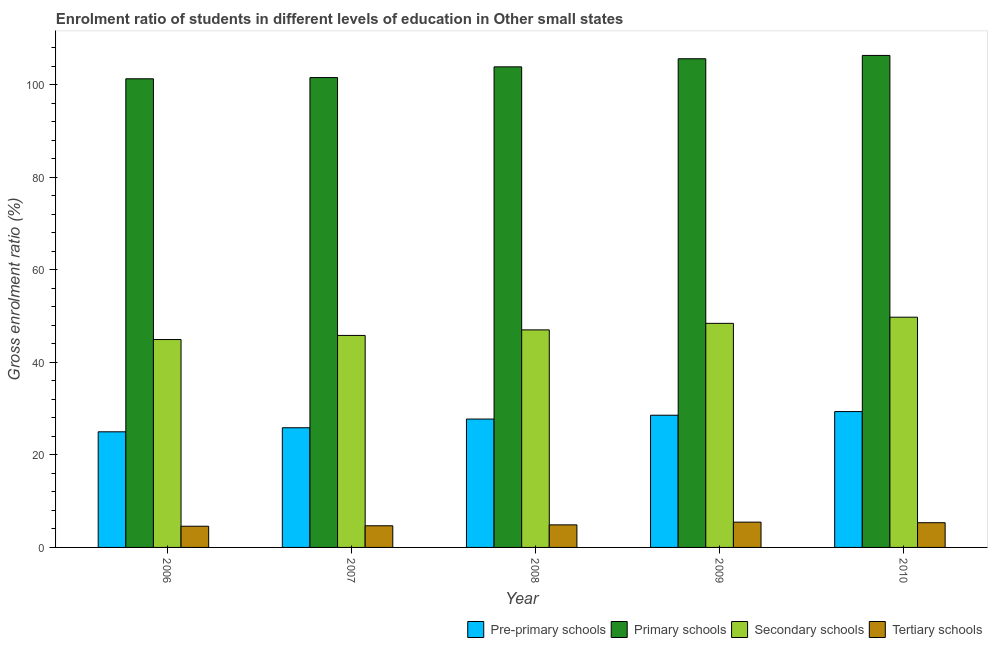How many different coloured bars are there?
Give a very brief answer. 4. How many groups of bars are there?
Offer a very short reply. 5. Are the number of bars per tick equal to the number of legend labels?
Make the answer very short. Yes. Are the number of bars on each tick of the X-axis equal?
Keep it short and to the point. Yes. How many bars are there on the 1st tick from the right?
Provide a succinct answer. 4. What is the label of the 5th group of bars from the left?
Your answer should be very brief. 2010. In how many cases, is the number of bars for a given year not equal to the number of legend labels?
Your response must be concise. 0. What is the gross enrolment ratio in primary schools in 2007?
Provide a short and direct response. 101.54. Across all years, what is the maximum gross enrolment ratio in tertiary schools?
Give a very brief answer. 5.46. Across all years, what is the minimum gross enrolment ratio in primary schools?
Offer a very short reply. 101.28. In which year was the gross enrolment ratio in pre-primary schools minimum?
Give a very brief answer. 2006. What is the total gross enrolment ratio in primary schools in the graph?
Keep it short and to the point. 518.62. What is the difference between the gross enrolment ratio in tertiary schools in 2007 and that in 2010?
Give a very brief answer. -0.66. What is the difference between the gross enrolment ratio in tertiary schools in 2010 and the gross enrolment ratio in pre-primary schools in 2009?
Give a very brief answer. -0.12. What is the average gross enrolment ratio in pre-primary schools per year?
Provide a succinct answer. 27.3. In the year 2009, what is the difference between the gross enrolment ratio in pre-primary schools and gross enrolment ratio in tertiary schools?
Offer a terse response. 0. What is the ratio of the gross enrolment ratio in pre-primary schools in 2007 to that in 2008?
Ensure brevity in your answer.  0.93. Is the difference between the gross enrolment ratio in pre-primary schools in 2007 and 2010 greater than the difference between the gross enrolment ratio in primary schools in 2007 and 2010?
Your response must be concise. No. What is the difference between the highest and the second highest gross enrolment ratio in tertiary schools?
Your response must be concise. 0.12. What is the difference between the highest and the lowest gross enrolment ratio in pre-primary schools?
Your answer should be compact. 4.37. Is it the case that in every year, the sum of the gross enrolment ratio in pre-primary schools and gross enrolment ratio in primary schools is greater than the sum of gross enrolment ratio in tertiary schools and gross enrolment ratio in secondary schools?
Provide a short and direct response. No. What does the 3rd bar from the left in 2007 represents?
Give a very brief answer. Secondary schools. What does the 2nd bar from the right in 2008 represents?
Give a very brief answer. Secondary schools. Is it the case that in every year, the sum of the gross enrolment ratio in pre-primary schools and gross enrolment ratio in primary schools is greater than the gross enrolment ratio in secondary schools?
Give a very brief answer. Yes. How many bars are there?
Offer a terse response. 20. Are all the bars in the graph horizontal?
Make the answer very short. No. How many years are there in the graph?
Offer a very short reply. 5. What is the difference between two consecutive major ticks on the Y-axis?
Your answer should be compact. 20. Are the values on the major ticks of Y-axis written in scientific E-notation?
Ensure brevity in your answer.  No. Does the graph contain any zero values?
Offer a terse response. No. Does the graph contain grids?
Your answer should be very brief. No. Where does the legend appear in the graph?
Your answer should be very brief. Bottom right. How many legend labels are there?
Keep it short and to the point. 4. What is the title of the graph?
Offer a terse response. Enrolment ratio of students in different levels of education in Other small states. What is the Gross enrolment ratio (%) of Pre-primary schools in 2006?
Your answer should be compact. 24.99. What is the Gross enrolment ratio (%) in Primary schools in 2006?
Your answer should be very brief. 101.28. What is the Gross enrolment ratio (%) in Secondary schools in 2006?
Offer a very short reply. 44.93. What is the Gross enrolment ratio (%) in Tertiary schools in 2006?
Provide a succinct answer. 4.58. What is the Gross enrolment ratio (%) of Pre-primary schools in 2007?
Your answer should be very brief. 25.86. What is the Gross enrolment ratio (%) of Primary schools in 2007?
Make the answer very short. 101.54. What is the Gross enrolment ratio (%) of Secondary schools in 2007?
Offer a very short reply. 45.82. What is the Gross enrolment ratio (%) in Tertiary schools in 2007?
Offer a very short reply. 4.68. What is the Gross enrolment ratio (%) in Pre-primary schools in 2008?
Make the answer very short. 27.74. What is the Gross enrolment ratio (%) in Primary schools in 2008?
Ensure brevity in your answer.  103.86. What is the Gross enrolment ratio (%) in Secondary schools in 2008?
Offer a very short reply. 47.01. What is the Gross enrolment ratio (%) in Tertiary schools in 2008?
Your answer should be compact. 4.88. What is the Gross enrolment ratio (%) in Pre-primary schools in 2009?
Your answer should be compact. 28.57. What is the Gross enrolment ratio (%) in Primary schools in 2009?
Your response must be concise. 105.61. What is the Gross enrolment ratio (%) in Secondary schools in 2009?
Offer a very short reply. 48.43. What is the Gross enrolment ratio (%) of Tertiary schools in 2009?
Provide a succinct answer. 5.46. What is the Gross enrolment ratio (%) in Pre-primary schools in 2010?
Offer a very short reply. 29.36. What is the Gross enrolment ratio (%) in Primary schools in 2010?
Make the answer very short. 106.33. What is the Gross enrolment ratio (%) in Secondary schools in 2010?
Provide a short and direct response. 49.76. What is the Gross enrolment ratio (%) in Tertiary schools in 2010?
Offer a very short reply. 5.34. Across all years, what is the maximum Gross enrolment ratio (%) of Pre-primary schools?
Offer a terse response. 29.36. Across all years, what is the maximum Gross enrolment ratio (%) in Primary schools?
Your response must be concise. 106.33. Across all years, what is the maximum Gross enrolment ratio (%) of Secondary schools?
Ensure brevity in your answer.  49.76. Across all years, what is the maximum Gross enrolment ratio (%) of Tertiary schools?
Your answer should be compact. 5.46. Across all years, what is the minimum Gross enrolment ratio (%) of Pre-primary schools?
Offer a terse response. 24.99. Across all years, what is the minimum Gross enrolment ratio (%) of Primary schools?
Provide a succinct answer. 101.28. Across all years, what is the minimum Gross enrolment ratio (%) in Secondary schools?
Your response must be concise. 44.93. Across all years, what is the minimum Gross enrolment ratio (%) of Tertiary schools?
Offer a terse response. 4.58. What is the total Gross enrolment ratio (%) of Pre-primary schools in the graph?
Offer a terse response. 136.52. What is the total Gross enrolment ratio (%) of Primary schools in the graph?
Your response must be concise. 518.62. What is the total Gross enrolment ratio (%) in Secondary schools in the graph?
Keep it short and to the point. 235.94. What is the total Gross enrolment ratio (%) of Tertiary schools in the graph?
Your response must be concise. 24.94. What is the difference between the Gross enrolment ratio (%) in Pre-primary schools in 2006 and that in 2007?
Offer a terse response. -0.88. What is the difference between the Gross enrolment ratio (%) of Primary schools in 2006 and that in 2007?
Provide a short and direct response. -0.26. What is the difference between the Gross enrolment ratio (%) in Secondary schools in 2006 and that in 2007?
Your response must be concise. -0.89. What is the difference between the Gross enrolment ratio (%) in Tertiary schools in 2006 and that in 2007?
Provide a short and direct response. -0.1. What is the difference between the Gross enrolment ratio (%) in Pre-primary schools in 2006 and that in 2008?
Ensure brevity in your answer.  -2.76. What is the difference between the Gross enrolment ratio (%) of Primary schools in 2006 and that in 2008?
Your answer should be compact. -2.58. What is the difference between the Gross enrolment ratio (%) in Secondary schools in 2006 and that in 2008?
Offer a very short reply. -2.09. What is the difference between the Gross enrolment ratio (%) of Tertiary schools in 2006 and that in 2008?
Offer a terse response. -0.3. What is the difference between the Gross enrolment ratio (%) of Pre-primary schools in 2006 and that in 2009?
Your response must be concise. -3.59. What is the difference between the Gross enrolment ratio (%) of Primary schools in 2006 and that in 2009?
Provide a short and direct response. -4.33. What is the difference between the Gross enrolment ratio (%) in Secondary schools in 2006 and that in 2009?
Your response must be concise. -3.5. What is the difference between the Gross enrolment ratio (%) in Tertiary schools in 2006 and that in 2009?
Your answer should be very brief. -0.88. What is the difference between the Gross enrolment ratio (%) in Pre-primary schools in 2006 and that in 2010?
Your answer should be very brief. -4.37. What is the difference between the Gross enrolment ratio (%) of Primary schools in 2006 and that in 2010?
Your response must be concise. -5.05. What is the difference between the Gross enrolment ratio (%) in Secondary schools in 2006 and that in 2010?
Offer a terse response. -4.83. What is the difference between the Gross enrolment ratio (%) of Tertiary schools in 2006 and that in 2010?
Your response must be concise. -0.76. What is the difference between the Gross enrolment ratio (%) of Pre-primary schools in 2007 and that in 2008?
Provide a succinct answer. -1.88. What is the difference between the Gross enrolment ratio (%) of Primary schools in 2007 and that in 2008?
Make the answer very short. -2.32. What is the difference between the Gross enrolment ratio (%) of Secondary schools in 2007 and that in 2008?
Provide a short and direct response. -1.2. What is the difference between the Gross enrolment ratio (%) of Tertiary schools in 2007 and that in 2008?
Keep it short and to the point. -0.2. What is the difference between the Gross enrolment ratio (%) in Pre-primary schools in 2007 and that in 2009?
Keep it short and to the point. -2.71. What is the difference between the Gross enrolment ratio (%) of Primary schools in 2007 and that in 2009?
Offer a very short reply. -4.07. What is the difference between the Gross enrolment ratio (%) of Secondary schools in 2007 and that in 2009?
Ensure brevity in your answer.  -2.61. What is the difference between the Gross enrolment ratio (%) in Tertiary schools in 2007 and that in 2009?
Ensure brevity in your answer.  -0.78. What is the difference between the Gross enrolment ratio (%) in Pre-primary schools in 2007 and that in 2010?
Your answer should be very brief. -3.49. What is the difference between the Gross enrolment ratio (%) of Primary schools in 2007 and that in 2010?
Give a very brief answer. -4.79. What is the difference between the Gross enrolment ratio (%) in Secondary schools in 2007 and that in 2010?
Your response must be concise. -3.94. What is the difference between the Gross enrolment ratio (%) in Tertiary schools in 2007 and that in 2010?
Offer a very short reply. -0.66. What is the difference between the Gross enrolment ratio (%) in Pre-primary schools in 2008 and that in 2009?
Your response must be concise. -0.83. What is the difference between the Gross enrolment ratio (%) in Primary schools in 2008 and that in 2009?
Your response must be concise. -1.75. What is the difference between the Gross enrolment ratio (%) in Secondary schools in 2008 and that in 2009?
Your answer should be compact. -1.41. What is the difference between the Gross enrolment ratio (%) of Tertiary schools in 2008 and that in 2009?
Your response must be concise. -0.59. What is the difference between the Gross enrolment ratio (%) of Pre-primary schools in 2008 and that in 2010?
Keep it short and to the point. -1.61. What is the difference between the Gross enrolment ratio (%) in Primary schools in 2008 and that in 2010?
Your answer should be very brief. -2.47. What is the difference between the Gross enrolment ratio (%) in Secondary schools in 2008 and that in 2010?
Your response must be concise. -2.74. What is the difference between the Gross enrolment ratio (%) in Tertiary schools in 2008 and that in 2010?
Offer a very short reply. -0.47. What is the difference between the Gross enrolment ratio (%) in Pre-primary schools in 2009 and that in 2010?
Provide a succinct answer. -0.79. What is the difference between the Gross enrolment ratio (%) of Primary schools in 2009 and that in 2010?
Your answer should be very brief. -0.72. What is the difference between the Gross enrolment ratio (%) of Secondary schools in 2009 and that in 2010?
Give a very brief answer. -1.33. What is the difference between the Gross enrolment ratio (%) of Tertiary schools in 2009 and that in 2010?
Offer a terse response. 0.12. What is the difference between the Gross enrolment ratio (%) of Pre-primary schools in 2006 and the Gross enrolment ratio (%) of Primary schools in 2007?
Provide a short and direct response. -76.56. What is the difference between the Gross enrolment ratio (%) of Pre-primary schools in 2006 and the Gross enrolment ratio (%) of Secondary schools in 2007?
Make the answer very short. -20.83. What is the difference between the Gross enrolment ratio (%) of Pre-primary schools in 2006 and the Gross enrolment ratio (%) of Tertiary schools in 2007?
Your answer should be very brief. 20.31. What is the difference between the Gross enrolment ratio (%) in Primary schools in 2006 and the Gross enrolment ratio (%) in Secondary schools in 2007?
Offer a terse response. 55.46. What is the difference between the Gross enrolment ratio (%) in Primary schools in 2006 and the Gross enrolment ratio (%) in Tertiary schools in 2007?
Give a very brief answer. 96.6. What is the difference between the Gross enrolment ratio (%) in Secondary schools in 2006 and the Gross enrolment ratio (%) in Tertiary schools in 2007?
Provide a succinct answer. 40.25. What is the difference between the Gross enrolment ratio (%) in Pre-primary schools in 2006 and the Gross enrolment ratio (%) in Primary schools in 2008?
Offer a terse response. -78.87. What is the difference between the Gross enrolment ratio (%) in Pre-primary schools in 2006 and the Gross enrolment ratio (%) in Secondary schools in 2008?
Offer a terse response. -22.03. What is the difference between the Gross enrolment ratio (%) of Pre-primary schools in 2006 and the Gross enrolment ratio (%) of Tertiary schools in 2008?
Your answer should be very brief. 20.11. What is the difference between the Gross enrolment ratio (%) in Primary schools in 2006 and the Gross enrolment ratio (%) in Secondary schools in 2008?
Keep it short and to the point. 54.26. What is the difference between the Gross enrolment ratio (%) in Primary schools in 2006 and the Gross enrolment ratio (%) in Tertiary schools in 2008?
Provide a short and direct response. 96.4. What is the difference between the Gross enrolment ratio (%) in Secondary schools in 2006 and the Gross enrolment ratio (%) in Tertiary schools in 2008?
Offer a very short reply. 40.05. What is the difference between the Gross enrolment ratio (%) in Pre-primary schools in 2006 and the Gross enrolment ratio (%) in Primary schools in 2009?
Ensure brevity in your answer.  -80.62. What is the difference between the Gross enrolment ratio (%) of Pre-primary schools in 2006 and the Gross enrolment ratio (%) of Secondary schools in 2009?
Your answer should be compact. -23.44. What is the difference between the Gross enrolment ratio (%) of Pre-primary schools in 2006 and the Gross enrolment ratio (%) of Tertiary schools in 2009?
Provide a succinct answer. 19.52. What is the difference between the Gross enrolment ratio (%) of Primary schools in 2006 and the Gross enrolment ratio (%) of Secondary schools in 2009?
Ensure brevity in your answer.  52.85. What is the difference between the Gross enrolment ratio (%) in Primary schools in 2006 and the Gross enrolment ratio (%) in Tertiary schools in 2009?
Make the answer very short. 95.81. What is the difference between the Gross enrolment ratio (%) in Secondary schools in 2006 and the Gross enrolment ratio (%) in Tertiary schools in 2009?
Make the answer very short. 39.46. What is the difference between the Gross enrolment ratio (%) of Pre-primary schools in 2006 and the Gross enrolment ratio (%) of Primary schools in 2010?
Ensure brevity in your answer.  -81.34. What is the difference between the Gross enrolment ratio (%) of Pre-primary schools in 2006 and the Gross enrolment ratio (%) of Secondary schools in 2010?
Provide a succinct answer. -24.77. What is the difference between the Gross enrolment ratio (%) in Pre-primary schools in 2006 and the Gross enrolment ratio (%) in Tertiary schools in 2010?
Your answer should be very brief. 19.64. What is the difference between the Gross enrolment ratio (%) in Primary schools in 2006 and the Gross enrolment ratio (%) in Secondary schools in 2010?
Your response must be concise. 51.52. What is the difference between the Gross enrolment ratio (%) of Primary schools in 2006 and the Gross enrolment ratio (%) of Tertiary schools in 2010?
Your answer should be very brief. 95.94. What is the difference between the Gross enrolment ratio (%) in Secondary schools in 2006 and the Gross enrolment ratio (%) in Tertiary schools in 2010?
Your answer should be compact. 39.59. What is the difference between the Gross enrolment ratio (%) in Pre-primary schools in 2007 and the Gross enrolment ratio (%) in Primary schools in 2008?
Your response must be concise. -78. What is the difference between the Gross enrolment ratio (%) of Pre-primary schools in 2007 and the Gross enrolment ratio (%) of Secondary schools in 2008?
Give a very brief answer. -21.15. What is the difference between the Gross enrolment ratio (%) in Pre-primary schools in 2007 and the Gross enrolment ratio (%) in Tertiary schools in 2008?
Make the answer very short. 20.99. What is the difference between the Gross enrolment ratio (%) in Primary schools in 2007 and the Gross enrolment ratio (%) in Secondary schools in 2008?
Give a very brief answer. 54.53. What is the difference between the Gross enrolment ratio (%) in Primary schools in 2007 and the Gross enrolment ratio (%) in Tertiary schools in 2008?
Your answer should be compact. 96.67. What is the difference between the Gross enrolment ratio (%) of Secondary schools in 2007 and the Gross enrolment ratio (%) of Tertiary schools in 2008?
Keep it short and to the point. 40.94. What is the difference between the Gross enrolment ratio (%) of Pre-primary schools in 2007 and the Gross enrolment ratio (%) of Primary schools in 2009?
Provide a succinct answer. -79.75. What is the difference between the Gross enrolment ratio (%) of Pre-primary schools in 2007 and the Gross enrolment ratio (%) of Secondary schools in 2009?
Make the answer very short. -22.56. What is the difference between the Gross enrolment ratio (%) in Pre-primary schools in 2007 and the Gross enrolment ratio (%) in Tertiary schools in 2009?
Offer a very short reply. 20.4. What is the difference between the Gross enrolment ratio (%) in Primary schools in 2007 and the Gross enrolment ratio (%) in Secondary schools in 2009?
Offer a terse response. 53.12. What is the difference between the Gross enrolment ratio (%) of Primary schools in 2007 and the Gross enrolment ratio (%) of Tertiary schools in 2009?
Offer a terse response. 96.08. What is the difference between the Gross enrolment ratio (%) in Secondary schools in 2007 and the Gross enrolment ratio (%) in Tertiary schools in 2009?
Make the answer very short. 40.35. What is the difference between the Gross enrolment ratio (%) of Pre-primary schools in 2007 and the Gross enrolment ratio (%) of Primary schools in 2010?
Offer a terse response. -80.47. What is the difference between the Gross enrolment ratio (%) of Pre-primary schools in 2007 and the Gross enrolment ratio (%) of Secondary schools in 2010?
Ensure brevity in your answer.  -23.89. What is the difference between the Gross enrolment ratio (%) in Pre-primary schools in 2007 and the Gross enrolment ratio (%) in Tertiary schools in 2010?
Your answer should be very brief. 20.52. What is the difference between the Gross enrolment ratio (%) in Primary schools in 2007 and the Gross enrolment ratio (%) in Secondary schools in 2010?
Your answer should be very brief. 51.79. What is the difference between the Gross enrolment ratio (%) in Primary schools in 2007 and the Gross enrolment ratio (%) in Tertiary schools in 2010?
Your answer should be compact. 96.2. What is the difference between the Gross enrolment ratio (%) in Secondary schools in 2007 and the Gross enrolment ratio (%) in Tertiary schools in 2010?
Your response must be concise. 40.47. What is the difference between the Gross enrolment ratio (%) in Pre-primary schools in 2008 and the Gross enrolment ratio (%) in Primary schools in 2009?
Ensure brevity in your answer.  -77.87. What is the difference between the Gross enrolment ratio (%) of Pre-primary schools in 2008 and the Gross enrolment ratio (%) of Secondary schools in 2009?
Provide a succinct answer. -20.68. What is the difference between the Gross enrolment ratio (%) of Pre-primary schools in 2008 and the Gross enrolment ratio (%) of Tertiary schools in 2009?
Offer a terse response. 22.28. What is the difference between the Gross enrolment ratio (%) of Primary schools in 2008 and the Gross enrolment ratio (%) of Secondary schools in 2009?
Provide a short and direct response. 55.43. What is the difference between the Gross enrolment ratio (%) of Primary schools in 2008 and the Gross enrolment ratio (%) of Tertiary schools in 2009?
Keep it short and to the point. 98.4. What is the difference between the Gross enrolment ratio (%) of Secondary schools in 2008 and the Gross enrolment ratio (%) of Tertiary schools in 2009?
Your answer should be very brief. 41.55. What is the difference between the Gross enrolment ratio (%) in Pre-primary schools in 2008 and the Gross enrolment ratio (%) in Primary schools in 2010?
Your response must be concise. -78.59. What is the difference between the Gross enrolment ratio (%) of Pre-primary schools in 2008 and the Gross enrolment ratio (%) of Secondary schools in 2010?
Your answer should be very brief. -22.01. What is the difference between the Gross enrolment ratio (%) of Pre-primary schools in 2008 and the Gross enrolment ratio (%) of Tertiary schools in 2010?
Your answer should be very brief. 22.4. What is the difference between the Gross enrolment ratio (%) in Primary schools in 2008 and the Gross enrolment ratio (%) in Secondary schools in 2010?
Keep it short and to the point. 54.1. What is the difference between the Gross enrolment ratio (%) in Primary schools in 2008 and the Gross enrolment ratio (%) in Tertiary schools in 2010?
Provide a succinct answer. 98.52. What is the difference between the Gross enrolment ratio (%) of Secondary schools in 2008 and the Gross enrolment ratio (%) of Tertiary schools in 2010?
Keep it short and to the point. 41.67. What is the difference between the Gross enrolment ratio (%) in Pre-primary schools in 2009 and the Gross enrolment ratio (%) in Primary schools in 2010?
Your response must be concise. -77.76. What is the difference between the Gross enrolment ratio (%) of Pre-primary schools in 2009 and the Gross enrolment ratio (%) of Secondary schools in 2010?
Make the answer very short. -21.19. What is the difference between the Gross enrolment ratio (%) in Pre-primary schools in 2009 and the Gross enrolment ratio (%) in Tertiary schools in 2010?
Your response must be concise. 23.23. What is the difference between the Gross enrolment ratio (%) in Primary schools in 2009 and the Gross enrolment ratio (%) in Secondary schools in 2010?
Your answer should be very brief. 55.85. What is the difference between the Gross enrolment ratio (%) of Primary schools in 2009 and the Gross enrolment ratio (%) of Tertiary schools in 2010?
Keep it short and to the point. 100.27. What is the difference between the Gross enrolment ratio (%) of Secondary schools in 2009 and the Gross enrolment ratio (%) of Tertiary schools in 2010?
Provide a succinct answer. 43.08. What is the average Gross enrolment ratio (%) in Pre-primary schools per year?
Give a very brief answer. 27.3. What is the average Gross enrolment ratio (%) in Primary schools per year?
Ensure brevity in your answer.  103.72. What is the average Gross enrolment ratio (%) in Secondary schools per year?
Offer a terse response. 47.19. What is the average Gross enrolment ratio (%) of Tertiary schools per year?
Offer a terse response. 4.99. In the year 2006, what is the difference between the Gross enrolment ratio (%) of Pre-primary schools and Gross enrolment ratio (%) of Primary schools?
Offer a very short reply. -76.29. In the year 2006, what is the difference between the Gross enrolment ratio (%) of Pre-primary schools and Gross enrolment ratio (%) of Secondary schools?
Your answer should be compact. -19.94. In the year 2006, what is the difference between the Gross enrolment ratio (%) in Pre-primary schools and Gross enrolment ratio (%) in Tertiary schools?
Your response must be concise. 20.41. In the year 2006, what is the difference between the Gross enrolment ratio (%) in Primary schools and Gross enrolment ratio (%) in Secondary schools?
Offer a terse response. 56.35. In the year 2006, what is the difference between the Gross enrolment ratio (%) of Primary schools and Gross enrolment ratio (%) of Tertiary schools?
Ensure brevity in your answer.  96.7. In the year 2006, what is the difference between the Gross enrolment ratio (%) in Secondary schools and Gross enrolment ratio (%) in Tertiary schools?
Make the answer very short. 40.35. In the year 2007, what is the difference between the Gross enrolment ratio (%) in Pre-primary schools and Gross enrolment ratio (%) in Primary schools?
Your response must be concise. -75.68. In the year 2007, what is the difference between the Gross enrolment ratio (%) of Pre-primary schools and Gross enrolment ratio (%) of Secondary schools?
Your answer should be very brief. -19.95. In the year 2007, what is the difference between the Gross enrolment ratio (%) of Pre-primary schools and Gross enrolment ratio (%) of Tertiary schools?
Provide a succinct answer. 21.18. In the year 2007, what is the difference between the Gross enrolment ratio (%) in Primary schools and Gross enrolment ratio (%) in Secondary schools?
Make the answer very short. 55.73. In the year 2007, what is the difference between the Gross enrolment ratio (%) of Primary schools and Gross enrolment ratio (%) of Tertiary schools?
Provide a succinct answer. 96.86. In the year 2007, what is the difference between the Gross enrolment ratio (%) in Secondary schools and Gross enrolment ratio (%) in Tertiary schools?
Your answer should be very brief. 41.14. In the year 2008, what is the difference between the Gross enrolment ratio (%) of Pre-primary schools and Gross enrolment ratio (%) of Primary schools?
Ensure brevity in your answer.  -76.12. In the year 2008, what is the difference between the Gross enrolment ratio (%) of Pre-primary schools and Gross enrolment ratio (%) of Secondary schools?
Provide a short and direct response. -19.27. In the year 2008, what is the difference between the Gross enrolment ratio (%) of Pre-primary schools and Gross enrolment ratio (%) of Tertiary schools?
Your response must be concise. 22.87. In the year 2008, what is the difference between the Gross enrolment ratio (%) of Primary schools and Gross enrolment ratio (%) of Secondary schools?
Ensure brevity in your answer.  56.85. In the year 2008, what is the difference between the Gross enrolment ratio (%) in Primary schools and Gross enrolment ratio (%) in Tertiary schools?
Your answer should be very brief. 98.98. In the year 2008, what is the difference between the Gross enrolment ratio (%) of Secondary schools and Gross enrolment ratio (%) of Tertiary schools?
Give a very brief answer. 42.14. In the year 2009, what is the difference between the Gross enrolment ratio (%) in Pre-primary schools and Gross enrolment ratio (%) in Primary schools?
Your answer should be compact. -77.04. In the year 2009, what is the difference between the Gross enrolment ratio (%) of Pre-primary schools and Gross enrolment ratio (%) of Secondary schools?
Your answer should be very brief. -19.86. In the year 2009, what is the difference between the Gross enrolment ratio (%) in Pre-primary schools and Gross enrolment ratio (%) in Tertiary schools?
Your answer should be very brief. 23.11. In the year 2009, what is the difference between the Gross enrolment ratio (%) of Primary schools and Gross enrolment ratio (%) of Secondary schools?
Your response must be concise. 57.18. In the year 2009, what is the difference between the Gross enrolment ratio (%) of Primary schools and Gross enrolment ratio (%) of Tertiary schools?
Ensure brevity in your answer.  100.14. In the year 2009, what is the difference between the Gross enrolment ratio (%) of Secondary schools and Gross enrolment ratio (%) of Tertiary schools?
Your answer should be very brief. 42.96. In the year 2010, what is the difference between the Gross enrolment ratio (%) of Pre-primary schools and Gross enrolment ratio (%) of Primary schools?
Your answer should be very brief. -76.97. In the year 2010, what is the difference between the Gross enrolment ratio (%) of Pre-primary schools and Gross enrolment ratio (%) of Secondary schools?
Offer a very short reply. -20.4. In the year 2010, what is the difference between the Gross enrolment ratio (%) of Pre-primary schools and Gross enrolment ratio (%) of Tertiary schools?
Your response must be concise. 24.01. In the year 2010, what is the difference between the Gross enrolment ratio (%) in Primary schools and Gross enrolment ratio (%) in Secondary schools?
Ensure brevity in your answer.  56.57. In the year 2010, what is the difference between the Gross enrolment ratio (%) in Primary schools and Gross enrolment ratio (%) in Tertiary schools?
Keep it short and to the point. 100.99. In the year 2010, what is the difference between the Gross enrolment ratio (%) in Secondary schools and Gross enrolment ratio (%) in Tertiary schools?
Provide a short and direct response. 44.41. What is the ratio of the Gross enrolment ratio (%) in Pre-primary schools in 2006 to that in 2007?
Provide a succinct answer. 0.97. What is the ratio of the Gross enrolment ratio (%) in Primary schools in 2006 to that in 2007?
Your answer should be compact. 1. What is the ratio of the Gross enrolment ratio (%) in Secondary schools in 2006 to that in 2007?
Ensure brevity in your answer.  0.98. What is the ratio of the Gross enrolment ratio (%) of Tertiary schools in 2006 to that in 2007?
Provide a succinct answer. 0.98. What is the ratio of the Gross enrolment ratio (%) in Pre-primary schools in 2006 to that in 2008?
Give a very brief answer. 0.9. What is the ratio of the Gross enrolment ratio (%) in Primary schools in 2006 to that in 2008?
Give a very brief answer. 0.98. What is the ratio of the Gross enrolment ratio (%) in Secondary schools in 2006 to that in 2008?
Give a very brief answer. 0.96. What is the ratio of the Gross enrolment ratio (%) of Tertiary schools in 2006 to that in 2008?
Keep it short and to the point. 0.94. What is the ratio of the Gross enrolment ratio (%) of Pre-primary schools in 2006 to that in 2009?
Provide a short and direct response. 0.87. What is the ratio of the Gross enrolment ratio (%) in Secondary schools in 2006 to that in 2009?
Keep it short and to the point. 0.93. What is the ratio of the Gross enrolment ratio (%) of Tertiary schools in 2006 to that in 2009?
Offer a very short reply. 0.84. What is the ratio of the Gross enrolment ratio (%) of Pre-primary schools in 2006 to that in 2010?
Your answer should be very brief. 0.85. What is the ratio of the Gross enrolment ratio (%) in Primary schools in 2006 to that in 2010?
Your answer should be very brief. 0.95. What is the ratio of the Gross enrolment ratio (%) of Secondary schools in 2006 to that in 2010?
Offer a very short reply. 0.9. What is the ratio of the Gross enrolment ratio (%) in Tertiary schools in 2006 to that in 2010?
Your answer should be very brief. 0.86. What is the ratio of the Gross enrolment ratio (%) of Pre-primary schools in 2007 to that in 2008?
Offer a very short reply. 0.93. What is the ratio of the Gross enrolment ratio (%) in Primary schools in 2007 to that in 2008?
Make the answer very short. 0.98. What is the ratio of the Gross enrolment ratio (%) in Secondary schools in 2007 to that in 2008?
Offer a terse response. 0.97. What is the ratio of the Gross enrolment ratio (%) in Tertiary schools in 2007 to that in 2008?
Ensure brevity in your answer.  0.96. What is the ratio of the Gross enrolment ratio (%) in Pre-primary schools in 2007 to that in 2009?
Give a very brief answer. 0.91. What is the ratio of the Gross enrolment ratio (%) in Primary schools in 2007 to that in 2009?
Provide a succinct answer. 0.96. What is the ratio of the Gross enrolment ratio (%) of Secondary schools in 2007 to that in 2009?
Your answer should be very brief. 0.95. What is the ratio of the Gross enrolment ratio (%) of Tertiary schools in 2007 to that in 2009?
Your answer should be compact. 0.86. What is the ratio of the Gross enrolment ratio (%) of Pre-primary schools in 2007 to that in 2010?
Your answer should be very brief. 0.88. What is the ratio of the Gross enrolment ratio (%) of Primary schools in 2007 to that in 2010?
Your answer should be compact. 0.95. What is the ratio of the Gross enrolment ratio (%) of Secondary schools in 2007 to that in 2010?
Ensure brevity in your answer.  0.92. What is the ratio of the Gross enrolment ratio (%) of Tertiary schools in 2007 to that in 2010?
Ensure brevity in your answer.  0.88. What is the ratio of the Gross enrolment ratio (%) of Primary schools in 2008 to that in 2009?
Ensure brevity in your answer.  0.98. What is the ratio of the Gross enrolment ratio (%) in Secondary schools in 2008 to that in 2009?
Ensure brevity in your answer.  0.97. What is the ratio of the Gross enrolment ratio (%) in Tertiary schools in 2008 to that in 2009?
Provide a succinct answer. 0.89. What is the ratio of the Gross enrolment ratio (%) in Pre-primary schools in 2008 to that in 2010?
Ensure brevity in your answer.  0.94. What is the ratio of the Gross enrolment ratio (%) of Primary schools in 2008 to that in 2010?
Your answer should be very brief. 0.98. What is the ratio of the Gross enrolment ratio (%) of Secondary schools in 2008 to that in 2010?
Your response must be concise. 0.94. What is the ratio of the Gross enrolment ratio (%) of Tertiary schools in 2008 to that in 2010?
Provide a succinct answer. 0.91. What is the ratio of the Gross enrolment ratio (%) of Pre-primary schools in 2009 to that in 2010?
Provide a succinct answer. 0.97. What is the ratio of the Gross enrolment ratio (%) of Primary schools in 2009 to that in 2010?
Offer a terse response. 0.99. What is the ratio of the Gross enrolment ratio (%) of Secondary schools in 2009 to that in 2010?
Provide a succinct answer. 0.97. What is the ratio of the Gross enrolment ratio (%) in Tertiary schools in 2009 to that in 2010?
Ensure brevity in your answer.  1.02. What is the difference between the highest and the second highest Gross enrolment ratio (%) in Pre-primary schools?
Provide a short and direct response. 0.79. What is the difference between the highest and the second highest Gross enrolment ratio (%) of Primary schools?
Make the answer very short. 0.72. What is the difference between the highest and the second highest Gross enrolment ratio (%) in Secondary schools?
Make the answer very short. 1.33. What is the difference between the highest and the second highest Gross enrolment ratio (%) in Tertiary schools?
Provide a short and direct response. 0.12. What is the difference between the highest and the lowest Gross enrolment ratio (%) in Pre-primary schools?
Give a very brief answer. 4.37. What is the difference between the highest and the lowest Gross enrolment ratio (%) in Primary schools?
Provide a short and direct response. 5.05. What is the difference between the highest and the lowest Gross enrolment ratio (%) of Secondary schools?
Your answer should be compact. 4.83. What is the difference between the highest and the lowest Gross enrolment ratio (%) of Tertiary schools?
Offer a terse response. 0.88. 